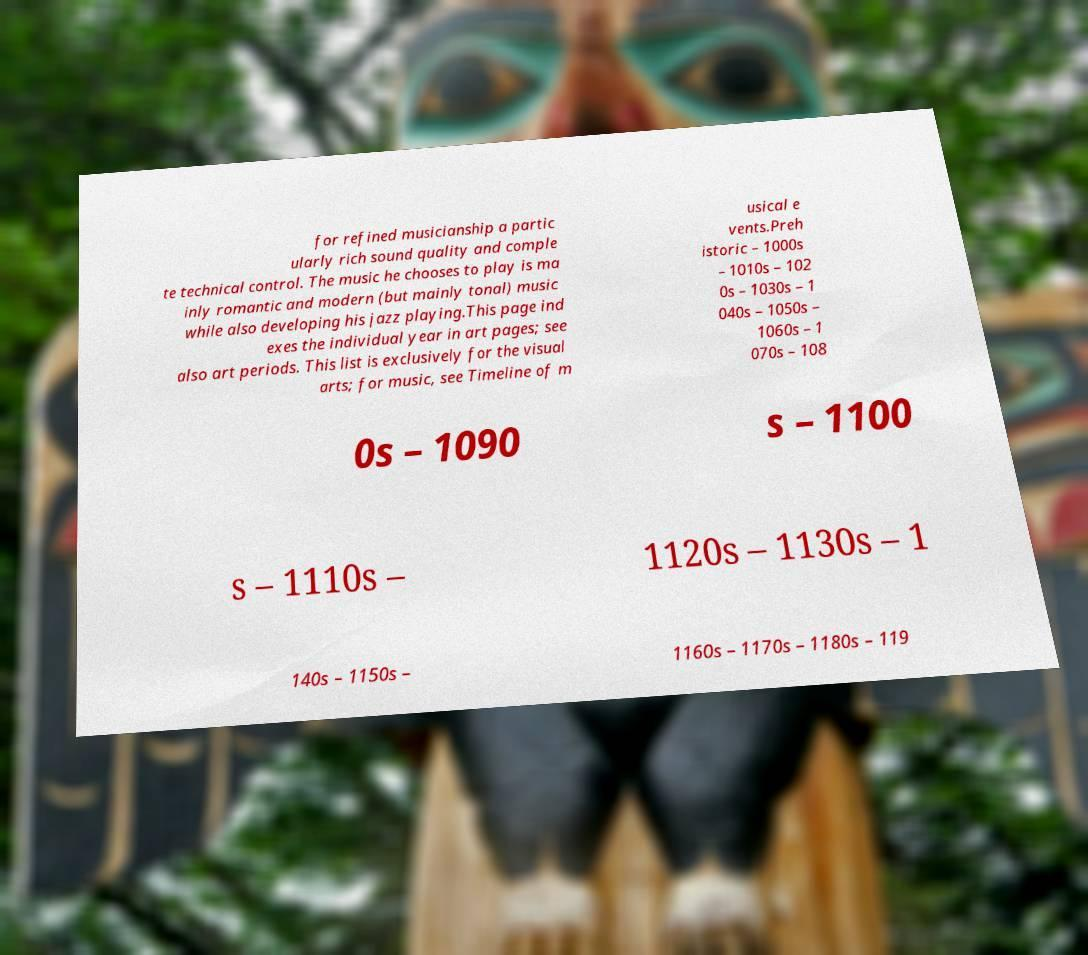Please identify and transcribe the text found in this image. for refined musicianship a partic ularly rich sound quality and comple te technical control. The music he chooses to play is ma inly romantic and modern (but mainly tonal) music while also developing his jazz playing.This page ind exes the individual year in art pages; see also art periods. This list is exclusively for the visual arts; for music, see Timeline of m usical e vents.Preh istoric – 1000s – 1010s – 102 0s – 1030s – 1 040s – 1050s – 1060s – 1 070s – 108 0s – 1090 s – 1100 s – 1110s – 1120s – 1130s – 1 140s – 1150s – 1160s – 1170s – 1180s – 119 